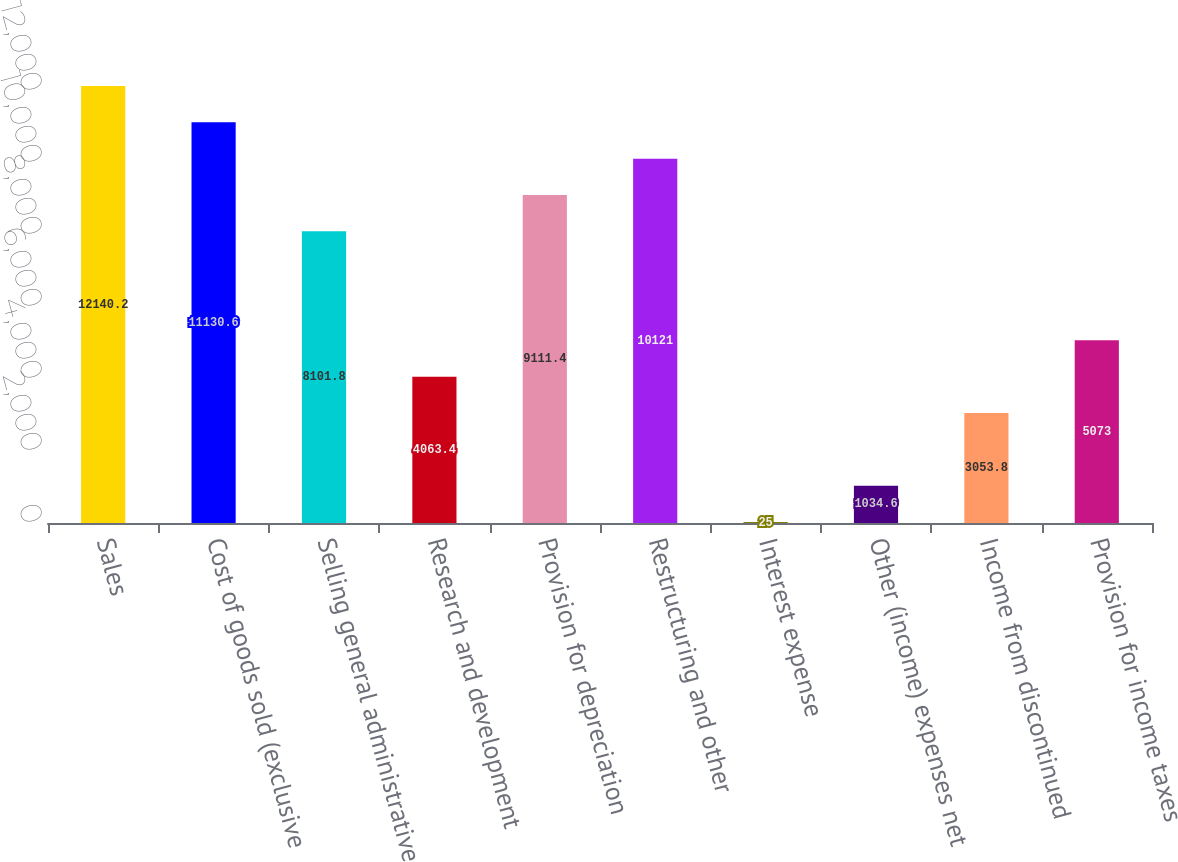Convert chart. <chart><loc_0><loc_0><loc_500><loc_500><bar_chart><fcel>Sales<fcel>Cost of goods sold (exclusive<fcel>Selling general administrative<fcel>Research and development<fcel>Provision for depreciation<fcel>Restructuring and other<fcel>Interest expense<fcel>Other (income) expenses net<fcel>Income from discontinued<fcel>Provision for income taxes<nl><fcel>12140.2<fcel>11130.6<fcel>8101.8<fcel>4063.4<fcel>9111.4<fcel>10121<fcel>25<fcel>1034.6<fcel>3053.8<fcel>5073<nl></chart> 